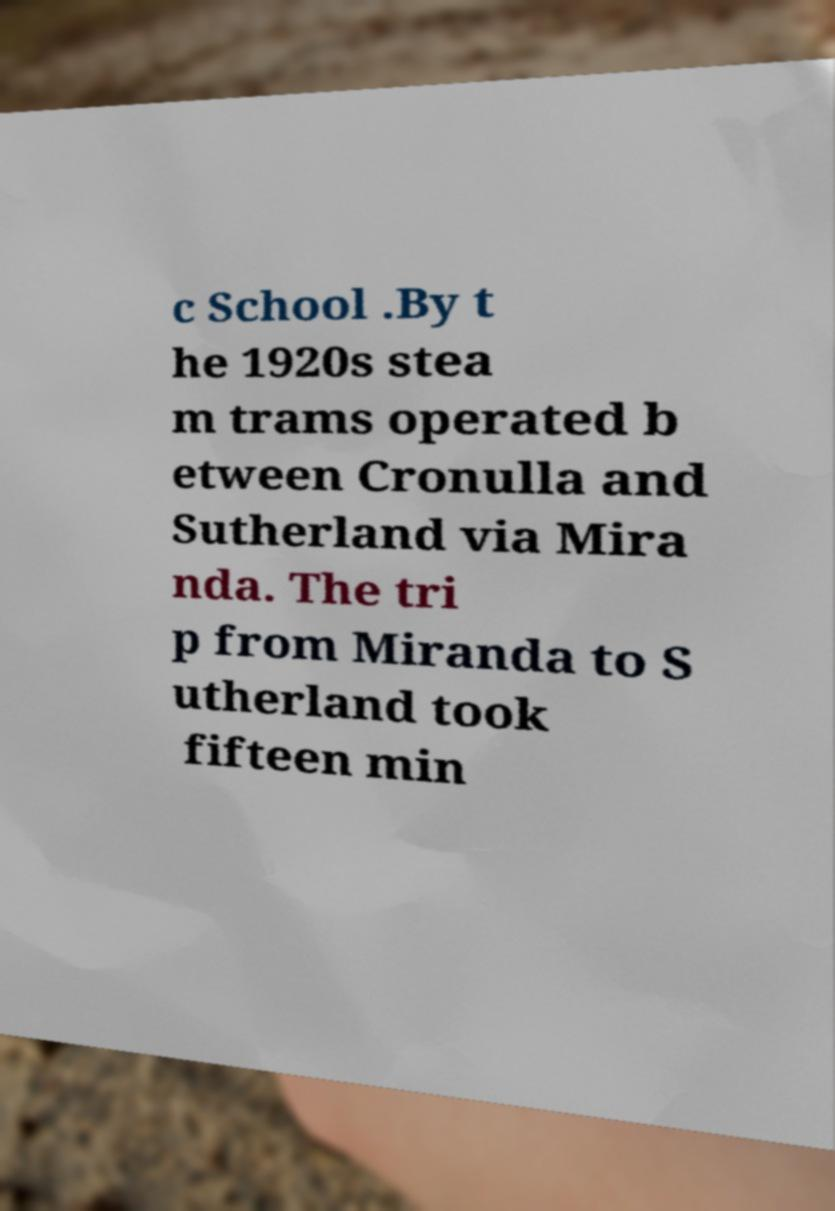Can you accurately transcribe the text from the provided image for me? c School .By t he 1920s stea m trams operated b etween Cronulla and Sutherland via Mira nda. The tri p from Miranda to S utherland took fifteen min 